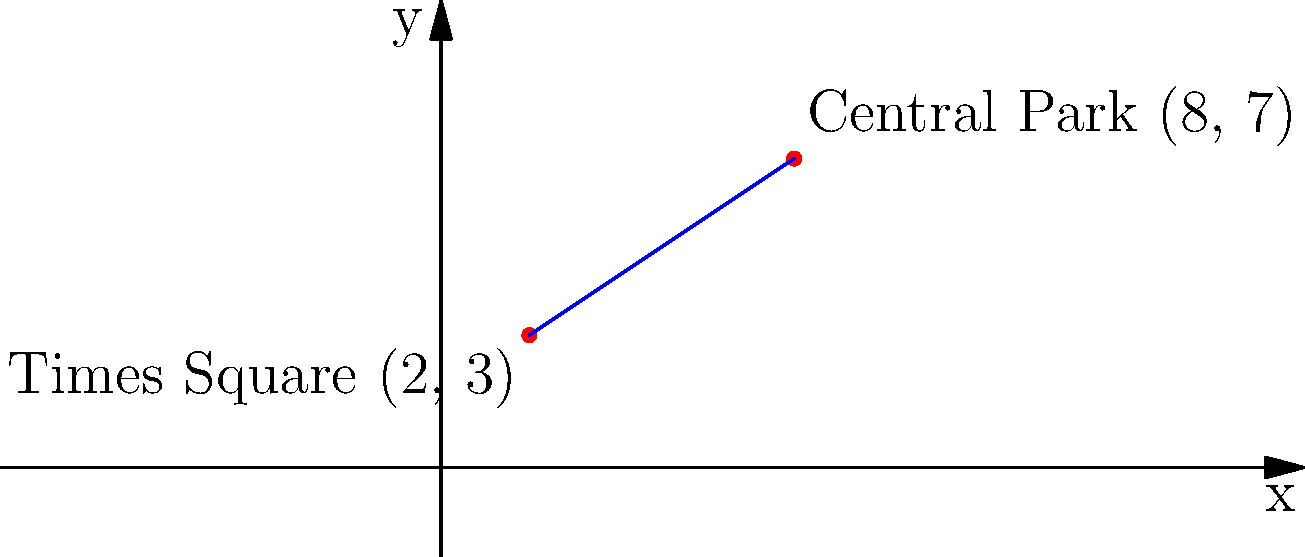On the New York City subway map represented by a coordinate grid, Times Square station is located at (2, 3) and Central Park station is at (8, 7). What are the coordinates of the midpoint of the subway line segment connecting these two stations? To find the midpoint of a line segment, we can use the midpoint formula:

$$ \text{Midpoint} = \left(\frac{x_1 + x_2}{2}, \frac{y_1 + y_2}{2}\right) $$

Where $(x_1, y_1)$ and $(x_2, y_2)$ are the coordinates of the two endpoints.

Let's apply this formula to our subway stations:

1. Times Square: $(x_1, y_1) = (2, 3)$
2. Central Park: $(x_2, y_2) = (8, 7)$

Now, let's calculate the x-coordinate of the midpoint:

$$ x = \frac{x_1 + x_2}{2} = \frac{2 + 8}{2} = \frac{10}{2} = 5 $$

Next, let's calculate the y-coordinate of the midpoint:

$$ y = \frac{y_1 + y_2}{2} = \frac{3 + 7}{2} = \frac{10}{2} = 5 $$

Therefore, the midpoint of the subway line segment is (5, 5).
Answer: (5, 5) 